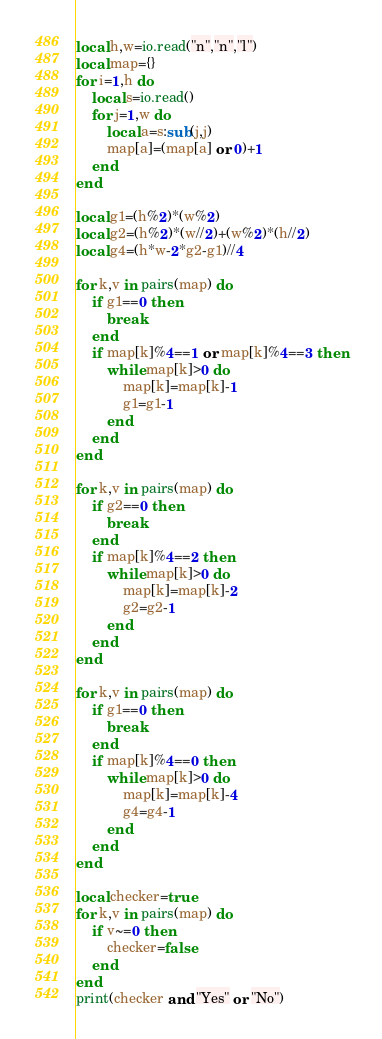Convert code to text. <code><loc_0><loc_0><loc_500><loc_500><_Lua_>local h,w=io.read("n","n","l")
local map={}
for i=1,h do
    local s=io.read()
    for j=1,w do
        local a=s:sub(j,j)
        map[a]=(map[a] or 0)+1
    end
end

local g1=(h%2)*(w%2)
local g2=(h%2)*(w//2)+(w%2)*(h//2)
local g4=(h*w-2*g2-g1)//4

for k,v in pairs(map) do
    if g1==0 then
        break
    end
    if map[k]%4==1 or map[k]%4==3 then
        while map[k]>0 do
            map[k]=map[k]-1
            g1=g1-1
        end
    end
end

for k,v in pairs(map) do
    if g2==0 then
        break
    end
    if map[k]%4==2 then
        while map[k]>0 do
            map[k]=map[k]-2
            g2=g2-1
        end
    end
end

for k,v in pairs(map) do
    if g1==0 then
        break
    end
    if map[k]%4==0 then
        while map[k]>0 do
            map[k]=map[k]-4
            g4=g4-1
        end
    end
end

local checker=true
for k,v in pairs(map) do
    if v~=0 then
        checker=false
    end
end
print(checker and "Yes" or "No")</code> 